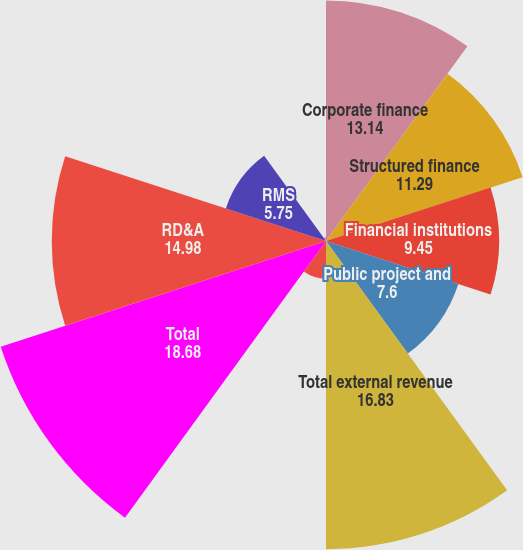Convert chart. <chart><loc_0><loc_0><loc_500><loc_500><pie_chart><fcel>Corporate finance<fcel>Structured finance<fcel>Financial institutions<fcel>Public project and<fcel>Total external revenue<fcel>Intersegment royalty<fcel>Total<fcel>RD&A<fcel>RMS<fcel>Professional services<nl><fcel>13.14%<fcel>11.29%<fcel>9.45%<fcel>7.6%<fcel>16.83%<fcel>2.06%<fcel>18.68%<fcel>14.98%<fcel>5.75%<fcel>0.22%<nl></chart> 